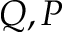Convert formula to latex. <formula><loc_0><loc_0><loc_500><loc_500>Q , P</formula> 